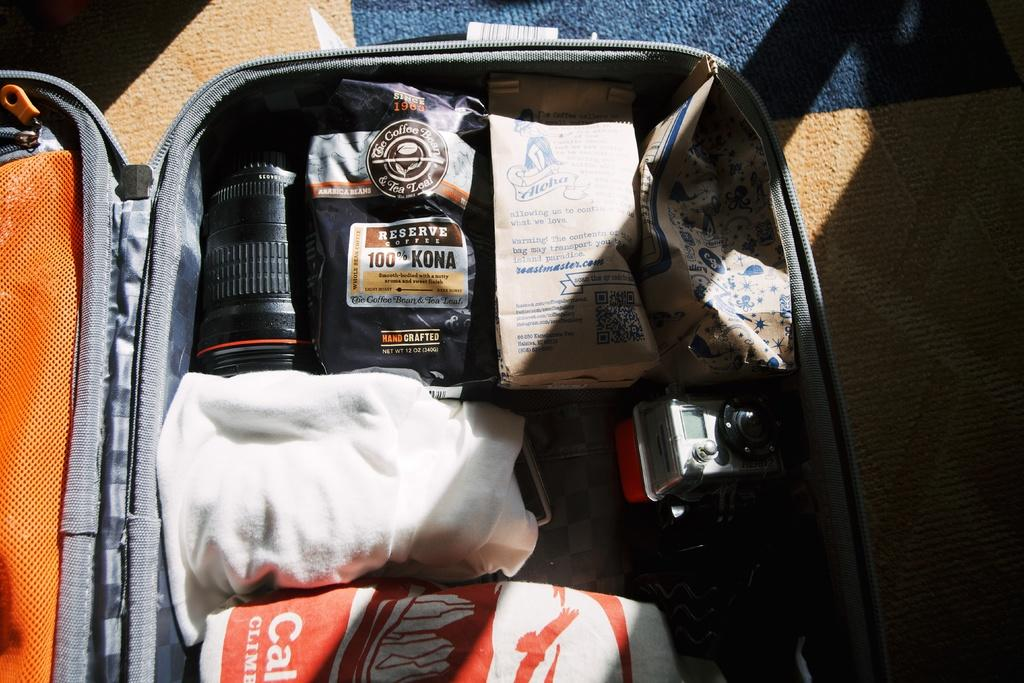What object can be seen in the image that is commonly used for traveling? There is a suitcase in the image that is commonly used for traveling. What is placed on the suitcase? There are products on the suitcase. How many kittens are playing with the leaf on the border of the image? There are no kittens or leaves present in the image, and therefore no such activity can be observed. 